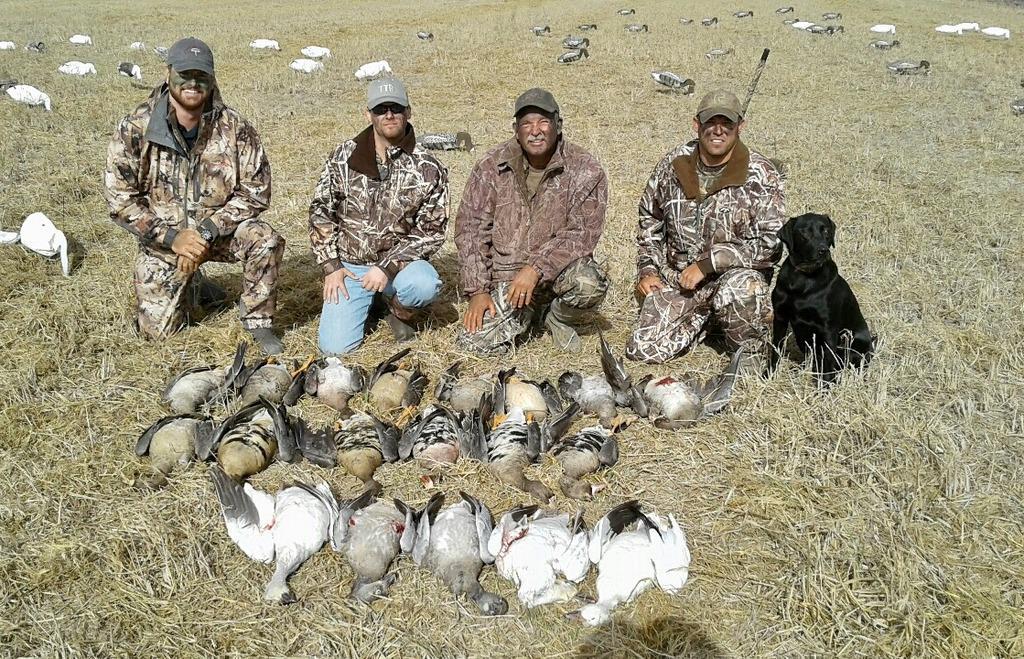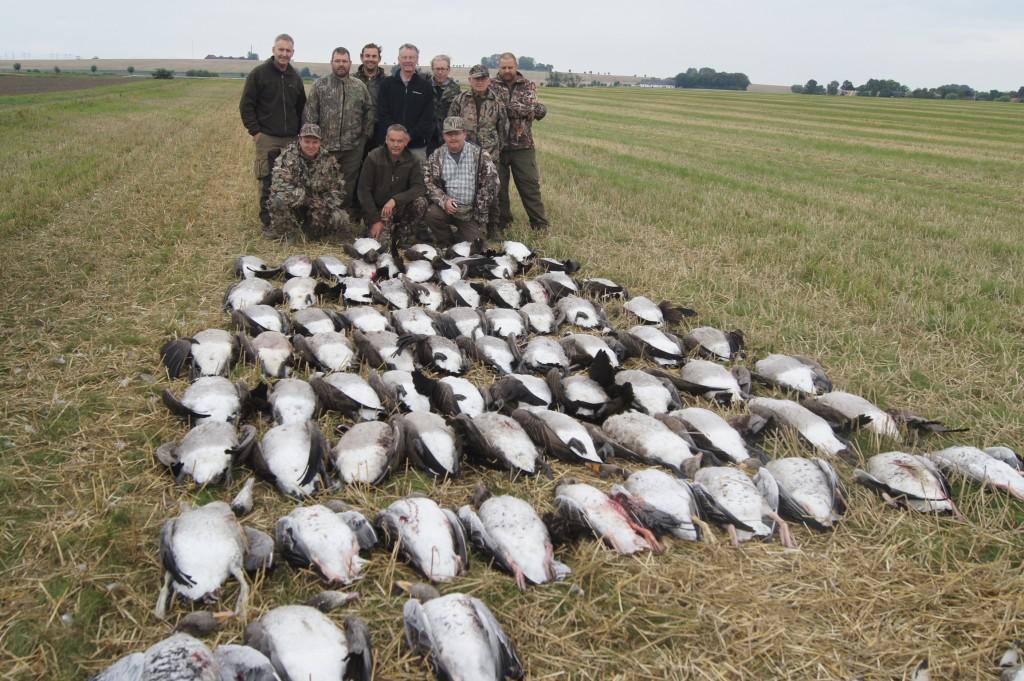The first image is the image on the left, the second image is the image on the right. Assess this claim about the two images: "There are exactly four people in the image on the left.". Correct or not? Answer yes or no. Yes. 